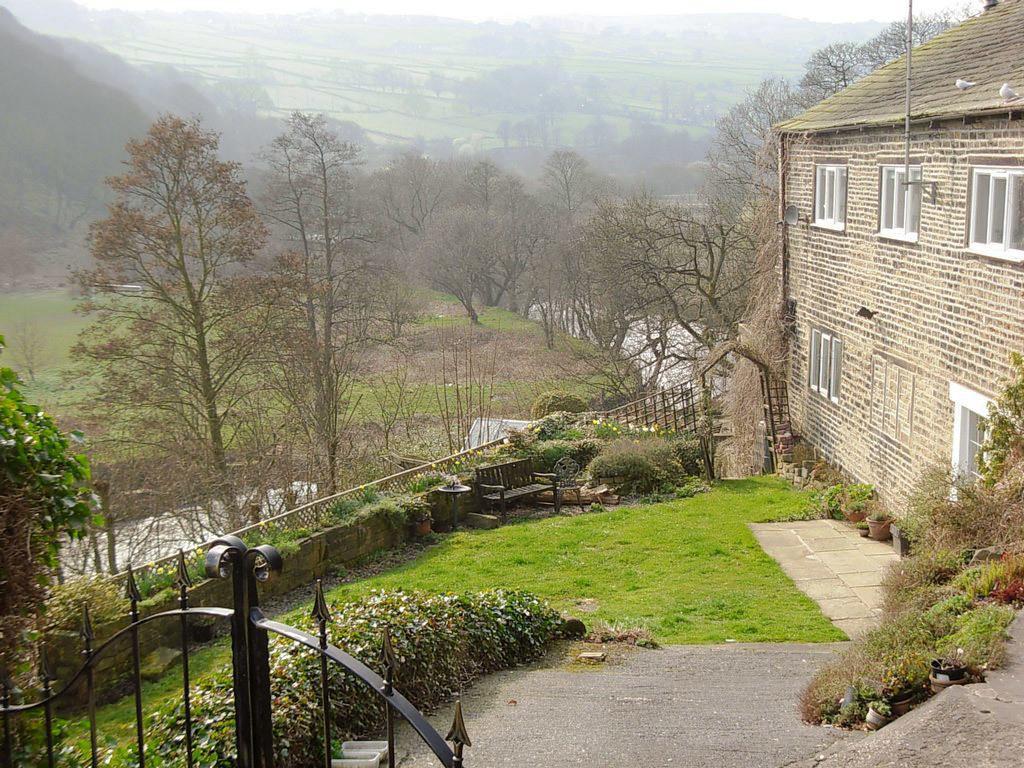How would you summarize this image in a sentence or two? In the background we can see the sky and its blur. In this picture we can see the trees, grass, railing, a black gate. On the right side of the picture we can see a building, windows, a pole, pots and the plants. We can see a bench near to a building. 